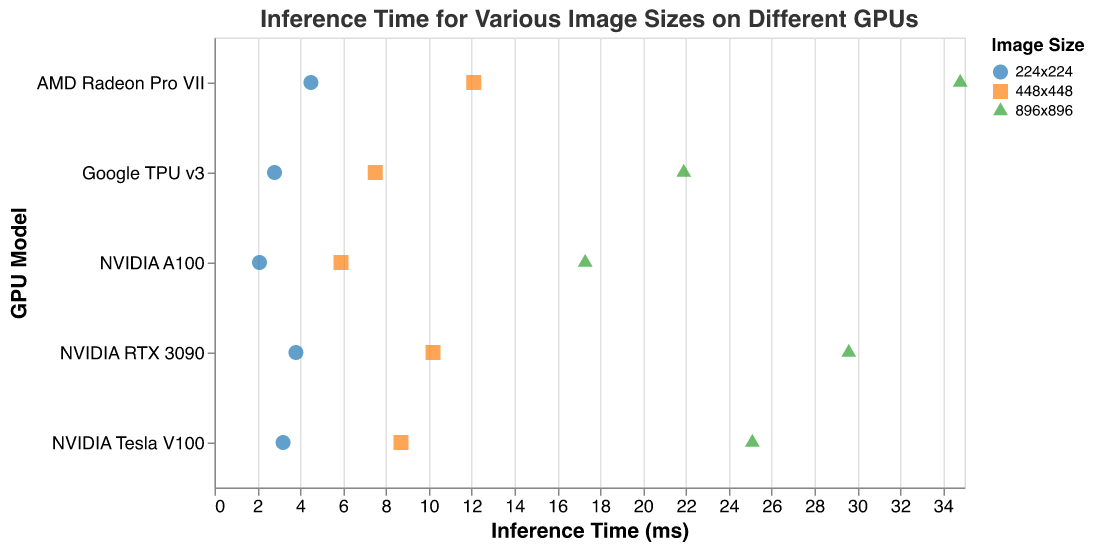Which GPU has the shortest inference time for the image size 896x896? The shortest inference time for 896x896 is found on the NVIDIA A100 GPU which has an inference time of 17.3 ms. To find this, look for the 896x896 image size and compare the inference times across all GPUs.
Answer: NVIDIA A100 How does the inference time for the image size 448x448 on NVIDIA RTX 3090 compare to the NVIDIA Tesla V100? The inference time for 448x448 on the NVIDIA RTX 3090 is 10.2 ms, while on the NVIDIA Tesla V100 it is 8.7 ms. Comparing these values, the NVIDIA RTX 3090 has a higher inference time by 10.2 - 8.7 = 1.5 ms.
Answer: 1.5 ms longer Which GPU shows the largest overall spread in inference times across all image sizes? The AMD Radeon Pro VII has the largest spread, with times ranging from 4.5 ms for 224x224 to 34.8 ms for 896x896, resulting in a spread of 34.8 - 4.5 = 30.3 ms. This is determined by identifying the difference between the maximum and minimum values for each GPU.
Answer: AMD Radeon Pro VII What is the average inference time for Google TPU v3 across all image sizes? Google TPU v3 has inference times of 2.8 ms, 7.5 ms, and 21.9 ms. Adding these gives 2.8 + 7.5 + 21.9 = 32.2 ms. Dividing by the number of image sizes (3) gives 32.2 / 3 = 10.73 ms.
Answer: 10.73 ms Which GPU provides the lowest inference time for the smallest image size, 224x224? The NVIDIA A100 has the lowest inference time for 224x224 at 2.1 ms. This is identified by comparing the inference times for 224x224 across all GPUs.
Answer: NVIDIA A100 How much faster is the NVIDIA A100 compared to AMD Radeon Pro VII for the image size, 896x896? The NVIDIA A100 has an inference time of 17.3 ms for 896x896, whereas the AMD Radeon Pro VII has 34.8 ms. The difference is 34.8 - 17.3 = 17.5 ms, making NVIDIA A100 significantly faster.
Answer: 17.5 ms faster Which GPU has the most balanced performance across different image sizes? The NVIDIA A100 has the most balanced performance with times of 2.1 ms, 5.9 ms, and 17.3 ms for 224x224, 448x448 and 896x896 respectively. This is determined by observing the relatively small spread and consistent increase in inference times.
Answer: NVIDIA A100 What is the inference time difference between the fastest and slowest GPU for the image size 448x448? The fastest GPU for 448x448 is the NVIDIA A100 with 5.9 ms, and the slowest is the AMD Radeon Pro VII with 12.1 ms. The difference is 12.1 - 5.9 = 6.2 ms.
Answer: 6.2 ms How do the inference times for 224x224 compare between NVIDIA Tesla V100 and Google TPU v3? The inference time for NVIDIA Tesla V100 for 224x224 is 3.2 ms, and for Google TPU v3 it is 2.8 ms. Google TPU v3 is slightly faster by 3.2 - 2.8 = 0.4 ms.
Answer: 0.4 ms faster 